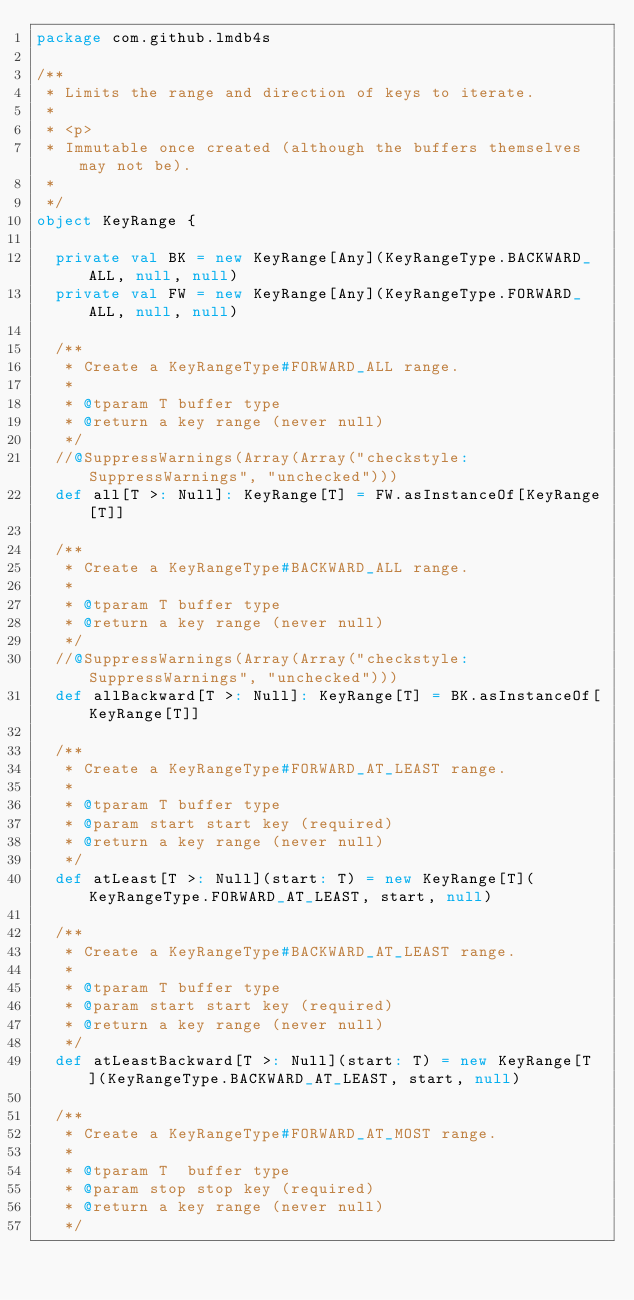Convert code to text. <code><loc_0><loc_0><loc_500><loc_500><_Scala_>package com.github.lmdb4s

/**
 * Limits the range and direction of keys to iterate.
 *
 * <p>
 * Immutable once created (although the buffers themselves may not be).
 *
 */
object KeyRange {

  private val BK = new KeyRange[Any](KeyRangeType.BACKWARD_ALL, null, null)
  private val FW = new KeyRange[Any](KeyRangeType.FORWARD_ALL, null, null)

  /**
   * Create a KeyRangeType#FORWARD_ALL range.
   *
   * @tparam T buffer type
   * @return a key range (never null)
   */
  //@SuppressWarnings(Array(Array("checkstyle:SuppressWarnings", "unchecked")))
  def all[T >: Null]: KeyRange[T] = FW.asInstanceOf[KeyRange[T]]

  /**
   * Create a KeyRangeType#BACKWARD_ALL range.
   *
   * @tparam T buffer type
   * @return a key range (never null)
   */
  //@SuppressWarnings(Array(Array("checkstyle:SuppressWarnings", "unchecked")))
  def allBackward[T >: Null]: KeyRange[T] = BK.asInstanceOf[KeyRange[T]]

  /**
   * Create a KeyRangeType#FORWARD_AT_LEAST range.
   *
   * @tparam T buffer type
   * @param start start key (required)
   * @return a key range (never null)
   */
  def atLeast[T >: Null](start: T) = new KeyRange[T](KeyRangeType.FORWARD_AT_LEAST, start, null)

  /**
   * Create a KeyRangeType#BACKWARD_AT_LEAST range.
   *
   * @tparam T buffer type
   * @param start start key (required)
   * @return a key range (never null)
   */
  def atLeastBackward[T >: Null](start: T) = new KeyRange[T](KeyRangeType.BACKWARD_AT_LEAST, start, null)

  /**
   * Create a KeyRangeType#FORWARD_AT_MOST range.
   *
   * @tparam T  buffer type
   * @param stop stop key (required)
   * @return a key range (never null)
   */</code> 